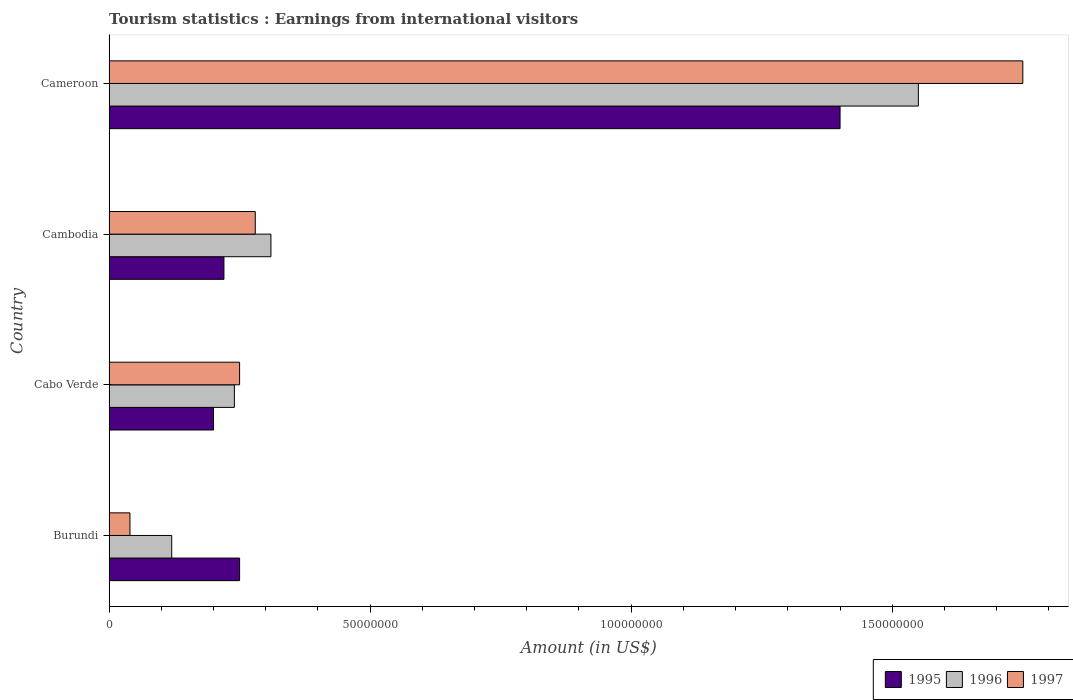Are the number of bars on each tick of the Y-axis equal?
Your response must be concise. Yes. How many bars are there on the 4th tick from the bottom?
Give a very brief answer. 3. What is the label of the 3rd group of bars from the top?
Your answer should be compact. Cabo Verde. In how many cases, is the number of bars for a given country not equal to the number of legend labels?
Your answer should be compact. 0. What is the earnings from international visitors in 1995 in Burundi?
Give a very brief answer. 2.50e+07. Across all countries, what is the maximum earnings from international visitors in 1996?
Give a very brief answer. 1.55e+08. In which country was the earnings from international visitors in 1995 maximum?
Give a very brief answer. Cameroon. In which country was the earnings from international visitors in 1996 minimum?
Keep it short and to the point. Burundi. What is the total earnings from international visitors in 1997 in the graph?
Keep it short and to the point. 2.32e+08. What is the difference between the earnings from international visitors in 1996 in Cabo Verde and that in Cambodia?
Keep it short and to the point. -7.00e+06. What is the difference between the earnings from international visitors in 1997 in Burundi and the earnings from international visitors in 1996 in Cabo Verde?
Offer a terse response. -2.00e+07. What is the average earnings from international visitors in 1996 per country?
Offer a very short reply. 5.55e+07. What is the ratio of the earnings from international visitors in 1995 in Cambodia to that in Cameroon?
Offer a very short reply. 0.16. Is the difference between the earnings from international visitors in 1997 in Burundi and Cameroon greater than the difference between the earnings from international visitors in 1996 in Burundi and Cameroon?
Ensure brevity in your answer.  No. What is the difference between the highest and the second highest earnings from international visitors in 1996?
Provide a succinct answer. 1.24e+08. What is the difference between the highest and the lowest earnings from international visitors in 1996?
Ensure brevity in your answer.  1.43e+08. What does the 3rd bar from the top in Cameroon represents?
Keep it short and to the point. 1995. How many countries are there in the graph?
Ensure brevity in your answer.  4. What is the difference between two consecutive major ticks on the X-axis?
Ensure brevity in your answer.  5.00e+07. Are the values on the major ticks of X-axis written in scientific E-notation?
Your response must be concise. No. Where does the legend appear in the graph?
Make the answer very short. Bottom right. How are the legend labels stacked?
Give a very brief answer. Horizontal. What is the title of the graph?
Your answer should be compact. Tourism statistics : Earnings from international visitors. What is the label or title of the X-axis?
Your answer should be compact. Amount (in US$). What is the label or title of the Y-axis?
Offer a terse response. Country. What is the Amount (in US$) of 1995 in Burundi?
Make the answer very short. 2.50e+07. What is the Amount (in US$) of 1996 in Burundi?
Make the answer very short. 1.20e+07. What is the Amount (in US$) of 1995 in Cabo Verde?
Offer a terse response. 2.00e+07. What is the Amount (in US$) in 1996 in Cabo Verde?
Give a very brief answer. 2.40e+07. What is the Amount (in US$) of 1997 in Cabo Verde?
Offer a very short reply. 2.50e+07. What is the Amount (in US$) of 1995 in Cambodia?
Offer a terse response. 2.20e+07. What is the Amount (in US$) of 1996 in Cambodia?
Give a very brief answer. 3.10e+07. What is the Amount (in US$) in 1997 in Cambodia?
Give a very brief answer. 2.80e+07. What is the Amount (in US$) in 1995 in Cameroon?
Your answer should be very brief. 1.40e+08. What is the Amount (in US$) of 1996 in Cameroon?
Your answer should be compact. 1.55e+08. What is the Amount (in US$) of 1997 in Cameroon?
Offer a very short reply. 1.75e+08. Across all countries, what is the maximum Amount (in US$) of 1995?
Offer a very short reply. 1.40e+08. Across all countries, what is the maximum Amount (in US$) in 1996?
Keep it short and to the point. 1.55e+08. Across all countries, what is the maximum Amount (in US$) of 1997?
Your answer should be very brief. 1.75e+08. Across all countries, what is the minimum Amount (in US$) of 1996?
Offer a very short reply. 1.20e+07. What is the total Amount (in US$) in 1995 in the graph?
Provide a short and direct response. 2.07e+08. What is the total Amount (in US$) of 1996 in the graph?
Your answer should be compact. 2.22e+08. What is the total Amount (in US$) in 1997 in the graph?
Provide a succinct answer. 2.32e+08. What is the difference between the Amount (in US$) in 1995 in Burundi and that in Cabo Verde?
Offer a terse response. 5.00e+06. What is the difference between the Amount (in US$) of 1996 in Burundi and that in Cabo Verde?
Make the answer very short. -1.20e+07. What is the difference between the Amount (in US$) of 1997 in Burundi and that in Cabo Verde?
Give a very brief answer. -2.10e+07. What is the difference between the Amount (in US$) of 1996 in Burundi and that in Cambodia?
Your response must be concise. -1.90e+07. What is the difference between the Amount (in US$) in 1997 in Burundi and that in Cambodia?
Your answer should be very brief. -2.40e+07. What is the difference between the Amount (in US$) of 1995 in Burundi and that in Cameroon?
Your answer should be very brief. -1.15e+08. What is the difference between the Amount (in US$) of 1996 in Burundi and that in Cameroon?
Your answer should be very brief. -1.43e+08. What is the difference between the Amount (in US$) of 1997 in Burundi and that in Cameroon?
Offer a terse response. -1.71e+08. What is the difference between the Amount (in US$) of 1995 in Cabo Verde and that in Cambodia?
Offer a very short reply. -2.00e+06. What is the difference between the Amount (in US$) of 1996 in Cabo Verde and that in Cambodia?
Keep it short and to the point. -7.00e+06. What is the difference between the Amount (in US$) of 1995 in Cabo Verde and that in Cameroon?
Your response must be concise. -1.20e+08. What is the difference between the Amount (in US$) of 1996 in Cabo Verde and that in Cameroon?
Offer a very short reply. -1.31e+08. What is the difference between the Amount (in US$) of 1997 in Cabo Verde and that in Cameroon?
Your answer should be very brief. -1.50e+08. What is the difference between the Amount (in US$) of 1995 in Cambodia and that in Cameroon?
Provide a short and direct response. -1.18e+08. What is the difference between the Amount (in US$) of 1996 in Cambodia and that in Cameroon?
Ensure brevity in your answer.  -1.24e+08. What is the difference between the Amount (in US$) in 1997 in Cambodia and that in Cameroon?
Provide a succinct answer. -1.47e+08. What is the difference between the Amount (in US$) in 1995 in Burundi and the Amount (in US$) in 1996 in Cabo Verde?
Provide a succinct answer. 1.00e+06. What is the difference between the Amount (in US$) in 1996 in Burundi and the Amount (in US$) in 1997 in Cabo Verde?
Your answer should be very brief. -1.30e+07. What is the difference between the Amount (in US$) in 1995 in Burundi and the Amount (in US$) in 1996 in Cambodia?
Provide a succinct answer. -6.00e+06. What is the difference between the Amount (in US$) of 1996 in Burundi and the Amount (in US$) of 1997 in Cambodia?
Your answer should be very brief. -1.60e+07. What is the difference between the Amount (in US$) of 1995 in Burundi and the Amount (in US$) of 1996 in Cameroon?
Make the answer very short. -1.30e+08. What is the difference between the Amount (in US$) in 1995 in Burundi and the Amount (in US$) in 1997 in Cameroon?
Your response must be concise. -1.50e+08. What is the difference between the Amount (in US$) in 1996 in Burundi and the Amount (in US$) in 1997 in Cameroon?
Give a very brief answer. -1.63e+08. What is the difference between the Amount (in US$) of 1995 in Cabo Verde and the Amount (in US$) of 1996 in Cambodia?
Keep it short and to the point. -1.10e+07. What is the difference between the Amount (in US$) of 1995 in Cabo Verde and the Amount (in US$) of 1997 in Cambodia?
Keep it short and to the point. -8.00e+06. What is the difference between the Amount (in US$) in 1995 in Cabo Verde and the Amount (in US$) in 1996 in Cameroon?
Give a very brief answer. -1.35e+08. What is the difference between the Amount (in US$) of 1995 in Cabo Verde and the Amount (in US$) of 1997 in Cameroon?
Offer a terse response. -1.55e+08. What is the difference between the Amount (in US$) in 1996 in Cabo Verde and the Amount (in US$) in 1997 in Cameroon?
Offer a terse response. -1.51e+08. What is the difference between the Amount (in US$) in 1995 in Cambodia and the Amount (in US$) in 1996 in Cameroon?
Provide a short and direct response. -1.33e+08. What is the difference between the Amount (in US$) of 1995 in Cambodia and the Amount (in US$) of 1997 in Cameroon?
Provide a short and direct response. -1.53e+08. What is the difference between the Amount (in US$) of 1996 in Cambodia and the Amount (in US$) of 1997 in Cameroon?
Provide a succinct answer. -1.44e+08. What is the average Amount (in US$) in 1995 per country?
Your response must be concise. 5.18e+07. What is the average Amount (in US$) of 1996 per country?
Your answer should be compact. 5.55e+07. What is the average Amount (in US$) in 1997 per country?
Your answer should be compact. 5.80e+07. What is the difference between the Amount (in US$) of 1995 and Amount (in US$) of 1996 in Burundi?
Provide a short and direct response. 1.30e+07. What is the difference between the Amount (in US$) in 1995 and Amount (in US$) in 1997 in Burundi?
Ensure brevity in your answer.  2.10e+07. What is the difference between the Amount (in US$) of 1996 and Amount (in US$) of 1997 in Burundi?
Your response must be concise. 8.00e+06. What is the difference between the Amount (in US$) in 1995 and Amount (in US$) in 1996 in Cabo Verde?
Your response must be concise. -4.00e+06. What is the difference between the Amount (in US$) of 1995 and Amount (in US$) of 1997 in Cabo Verde?
Give a very brief answer. -5.00e+06. What is the difference between the Amount (in US$) in 1995 and Amount (in US$) in 1996 in Cambodia?
Your answer should be very brief. -9.00e+06. What is the difference between the Amount (in US$) of 1995 and Amount (in US$) of 1997 in Cambodia?
Offer a very short reply. -6.00e+06. What is the difference between the Amount (in US$) in 1995 and Amount (in US$) in 1996 in Cameroon?
Make the answer very short. -1.50e+07. What is the difference between the Amount (in US$) of 1995 and Amount (in US$) of 1997 in Cameroon?
Your answer should be very brief. -3.50e+07. What is the difference between the Amount (in US$) of 1996 and Amount (in US$) of 1997 in Cameroon?
Keep it short and to the point. -2.00e+07. What is the ratio of the Amount (in US$) of 1995 in Burundi to that in Cabo Verde?
Offer a very short reply. 1.25. What is the ratio of the Amount (in US$) in 1997 in Burundi to that in Cabo Verde?
Provide a short and direct response. 0.16. What is the ratio of the Amount (in US$) of 1995 in Burundi to that in Cambodia?
Keep it short and to the point. 1.14. What is the ratio of the Amount (in US$) in 1996 in Burundi to that in Cambodia?
Your answer should be compact. 0.39. What is the ratio of the Amount (in US$) of 1997 in Burundi to that in Cambodia?
Give a very brief answer. 0.14. What is the ratio of the Amount (in US$) of 1995 in Burundi to that in Cameroon?
Your answer should be compact. 0.18. What is the ratio of the Amount (in US$) of 1996 in Burundi to that in Cameroon?
Provide a succinct answer. 0.08. What is the ratio of the Amount (in US$) in 1997 in Burundi to that in Cameroon?
Ensure brevity in your answer.  0.02. What is the ratio of the Amount (in US$) in 1996 in Cabo Verde to that in Cambodia?
Provide a short and direct response. 0.77. What is the ratio of the Amount (in US$) in 1997 in Cabo Verde to that in Cambodia?
Provide a short and direct response. 0.89. What is the ratio of the Amount (in US$) in 1995 in Cabo Verde to that in Cameroon?
Your answer should be compact. 0.14. What is the ratio of the Amount (in US$) of 1996 in Cabo Verde to that in Cameroon?
Ensure brevity in your answer.  0.15. What is the ratio of the Amount (in US$) in 1997 in Cabo Verde to that in Cameroon?
Make the answer very short. 0.14. What is the ratio of the Amount (in US$) of 1995 in Cambodia to that in Cameroon?
Give a very brief answer. 0.16. What is the ratio of the Amount (in US$) in 1997 in Cambodia to that in Cameroon?
Your response must be concise. 0.16. What is the difference between the highest and the second highest Amount (in US$) in 1995?
Provide a short and direct response. 1.15e+08. What is the difference between the highest and the second highest Amount (in US$) in 1996?
Give a very brief answer. 1.24e+08. What is the difference between the highest and the second highest Amount (in US$) in 1997?
Your response must be concise. 1.47e+08. What is the difference between the highest and the lowest Amount (in US$) of 1995?
Keep it short and to the point. 1.20e+08. What is the difference between the highest and the lowest Amount (in US$) of 1996?
Provide a short and direct response. 1.43e+08. What is the difference between the highest and the lowest Amount (in US$) of 1997?
Provide a succinct answer. 1.71e+08. 